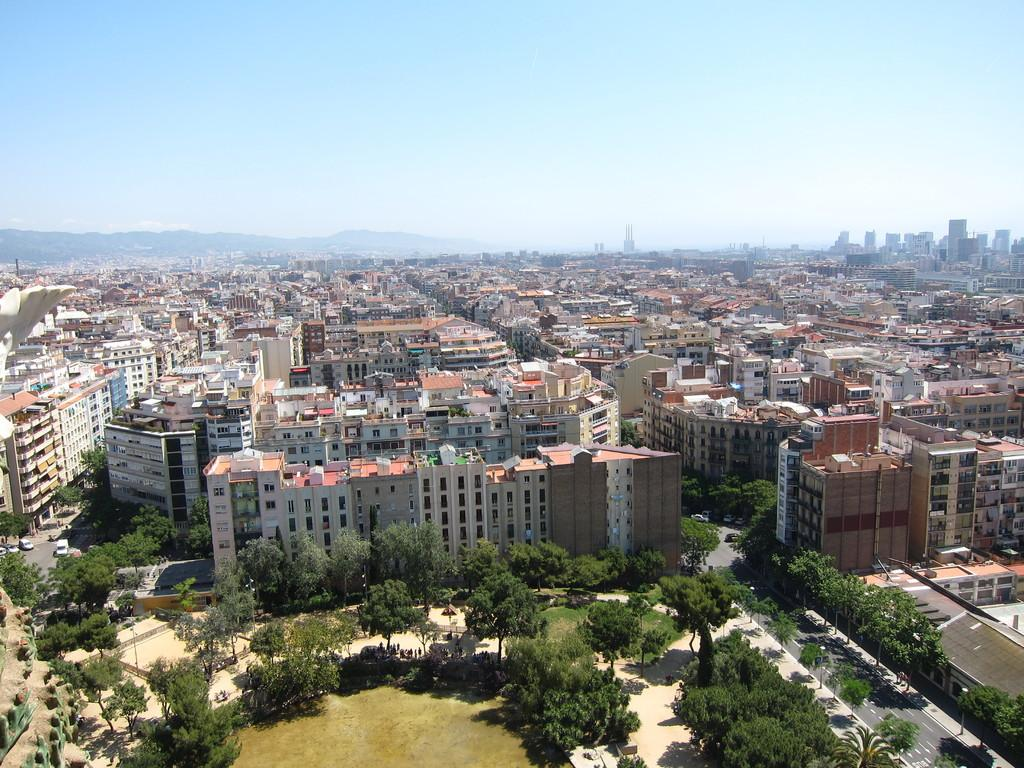What type of structures can be seen in the image? There are buildings in the image. What other natural elements are present in the image? There are trees in the image. What mode of transportation can be seen on the road in the image? There are vehicles on the road in the image. What can be seen in the background of the image? The sky is visible in the background of the image. What is the tendency of the roots in the image? There are no roots present in the image; it features buildings, trees, vehicles, and the sky. How do the waves interact with the buildings in the image? There are no waves present in the image; it features buildings, trees, vehicles, and the sky. 